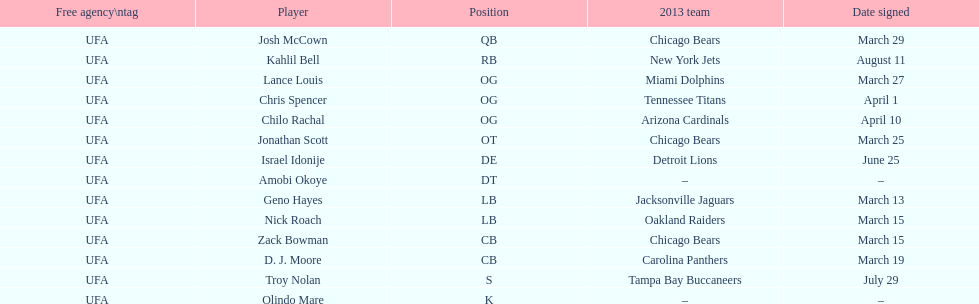Signed the same date as "april fools day". Chris Spencer. 